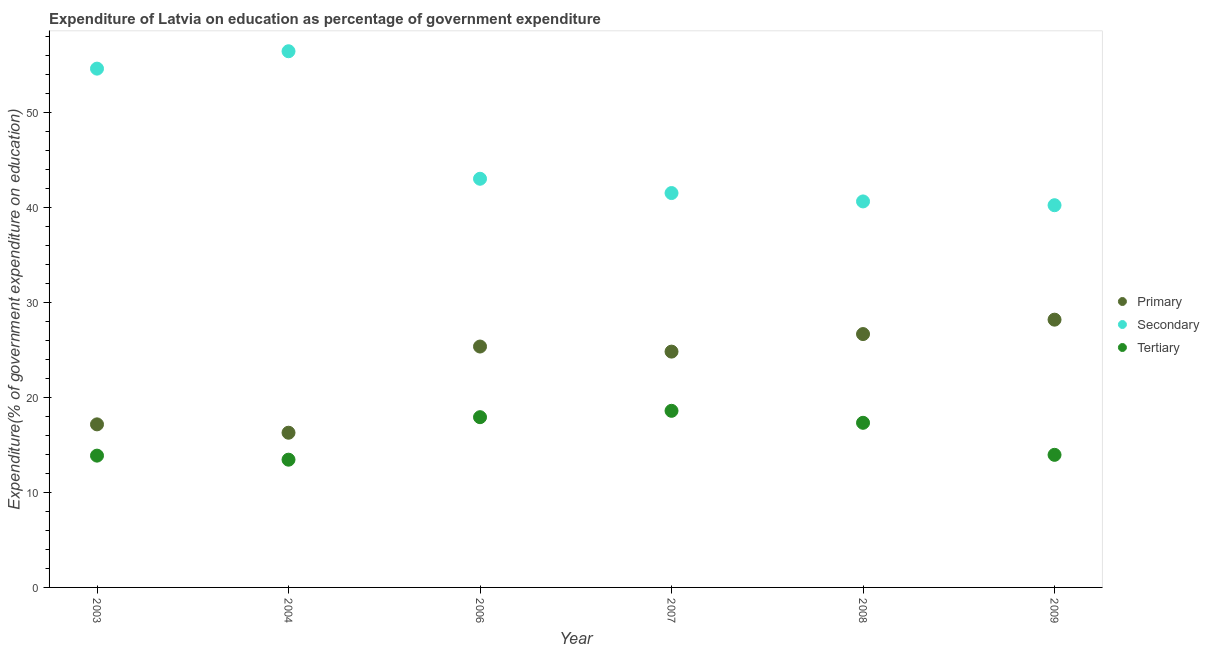Is the number of dotlines equal to the number of legend labels?
Your answer should be compact. Yes. What is the expenditure on primary education in 2007?
Ensure brevity in your answer.  24.82. Across all years, what is the maximum expenditure on secondary education?
Give a very brief answer. 56.45. Across all years, what is the minimum expenditure on secondary education?
Keep it short and to the point. 40.24. In which year was the expenditure on tertiary education minimum?
Your answer should be compact. 2004. What is the total expenditure on secondary education in the graph?
Keep it short and to the point. 276.47. What is the difference between the expenditure on tertiary education in 2004 and that in 2008?
Offer a terse response. -3.88. What is the difference between the expenditure on primary education in 2009 and the expenditure on secondary education in 2008?
Your response must be concise. -12.45. What is the average expenditure on tertiary education per year?
Your answer should be compact. 15.85. In the year 2004, what is the difference between the expenditure on tertiary education and expenditure on secondary education?
Your answer should be compact. -43. In how many years, is the expenditure on primary education greater than 20 %?
Keep it short and to the point. 4. What is the ratio of the expenditure on secondary education in 2004 to that in 2009?
Your answer should be compact. 1.4. Is the expenditure on tertiary education in 2004 less than that in 2008?
Your response must be concise. Yes. What is the difference between the highest and the second highest expenditure on primary education?
Provide a short and direct response. 1.52. What is the difference between the highest and the lowest expenditure on primary education?
Provide a short and direct response. 11.9. In how many years, is the expenditure on tertiary education greater than the average expenditure on tertiary education taken over all years?
Your response must be concise. 3. Is it the case that in every year, the sum of the expenditure on primary education and expenditure on secondary education is greater than the expenditure on tertiary education?
Your answer should be compact. Yes. Is the expenditure on secondary education strictly less than the expenditure on primary education over the years?
Keep it short and to the point. No. How many dotlines are there?
Provide a succinct answer. 3. How many years are there in the graph?
Ensure brevity in your answer.  6. Does the graph contain any zero values?
Ensure brevity in your answer.  No. Does the graph contain grids?
Offer a terse response. No. Where does the legend appear in the graph?
Provide a succinct answer. Center right. What is the title of the graph?
Offer a very short reply. Expenditure of Latvia on education as percentage of government expenditure. What is the label or title of the X-axis?
Provide a succinct answer. Year. What is the label or title of the Y-axis?
Make the answer very short. Expenditure(% of government expenditure on education). What is the Expenditure(% of government expenditure on education) in Primary in 2003?
Your answer should be compact. 17.17. What is the Expenditure(% of government expenditure on education) of Secondary in 2003?
Give a very brief answer. 54.61. What is the Expenditure(% of government expenditure on education) in Tertiary in 2003?
Offer a terse response. 13.87. What is the Expenditure(% of government expenditure on education) in Primary in 2004?
Make the answer very short. 16.29. What is the Expenditure(% of government expenditure on education) of Secondary in 2004?
Provide a short and direct response. 56.45. What is the Expenditure(% of government expenditure on education) in Tertiary in 2004?
Your response must be concise. 13.45. What is the Expenditure(% of government expenditure on education) of Primary in 2006?
Your answer should be compact. 25.36. What is the Expenditure(% of government expenditure on education) in Secondary in 2006?
Offer a terse response. 43.02. What is the Expenditure(% of government expenditure on education) in Tertiary in 2006?
Offer a terse response. 17.92. What is the Expenditure(% of government expenditure on education) of Primary in 2007?
Offer a terse response. 24.82. What is the Expenditure(% of government expenditure on education) in Secondary in 2007?
Your answer should be compact. 41.52. What is the Expenditure(% of government expenditure on education) of Tertiary in 2007?
Keep it short and to the point. 18.59. What is the Expenditure(% of government expenditure on education) in Primary in 2008?
Provide a short and direct response. 26.67. What is the Expenditure(% of government expenditure on education) in Secondary in 2008?
Ensure brevity in your answer.  40.64. What is the Expenditure(% of government expenditure on education) of Tertiary in 2008?
Provide a short and direct response. 17.33. What is the Expenditure(% of government expenditure on education) of Primary in 2009?
Ensure brevity in your answer.  28.19. What is the Expenditure(% of government expenditure on education) of Secondary in 2009?
Offer a very short reply. 40.24. What is the Expenditure(% of government expenditure on education) of Tertiary in 2009?
Offer a terse response. 13.96. Across all years, what is the maximum Expenditure(% of government expenditure on education) in Primary?
Ensure brevity in your answer.  28.19. Across all years, what is the maximum Expenditure(% of government expenditure on education) of Secondary?
Offer a terse response. 56.45. Across all years, what is the maximum Expenditure(% of government expenditure on education) of Tertiary?
Your answer should be compact. 18.59. Across all years, what is the minimum Expenditure(% of government expenditure on education) of Primary?
Offer a very short reply. 16.29. Across all years, what is the minimum Expenditure(% of government expenditure on education) of Secondary?
Give a very brief answer. 40.24. Across all years, what is the minimum Expenditure(% of government expenditure on education) of Tertiary?
Give a very brief answer. 13.45. What is the total Expenditure(% of government expenditure on education) of Primary in the graph?
Ensure brevity in your answer.  138.5. What is the total Expenditure(% of government expenditure on education) of Secondary in the graph?
Your answer should be compact. 276.47. What is the total Expenditure(% of government expenditure on education) in Tertiary in the graph?
Your answer should be very brief. 95.13. What is the difference between the Expenditure(% of government expenditure on education) of Primary in 2003 and that in 2004?
Offer a terse response. 0.88. What is the difference between the Expenditure(% of government expenditure on education) in Secondary in 2003 and that in 2004?
Keep it short and to the point. -1.83. What is the difference between the Expenditure(% of government expenditure on education) in Tertiary in 2003 and that in 2004?
Your response must be concise. 0.43. What is the difference between the Expenditure(% of government expenditure on education) of Primary in 2003 and that in 2006?
Your answer should be very brief. -8.19. What is the difference between the Expenditure(% of government expenditure on education) of Secondary in 2003 and that in 2006?
Provide a short and direct response. 11.59. What is the difference between the Expenditure(% of government expenditure on education) of Tertiary in 2003 and that in 2006?
Provide a short and direct response. -4.05. What is the difference between the Expenditure(% of government expenditure on education) of Primary in 2003 and that in 2007?
Make the answer very short. -7.66. What is the difference between the Expenditure(% of government expenditure on education) of Secondary in 2003 and that in 2007?
Offer a terse response. 13.1. What is the difference between the Expenditure(% of government expenditure on education) in Tertiary in 2003 and that in 2007?
Give a very brief answer. -4.72. What is the difference between the Expenditure(% of government expenditure on education) in Primary in 2003 and that in 2008?
Offer a terse response. -9.51. What is the difference between the Expenditure(% of government expenditure on education) of Secondary in 2003 and that in 2008?
Your answer should be very brief. 13.98. What is the difference between the Expenditure(% of government expenditure on education) in Tertiary in 2003 and that in 2008?
Ensure brevity in your answer.  -3.46. What is the difference between the Expenditure(% of government expenditure on education) in Primary in 2003 and that in 2009?
Your answer should be very brief. -11.02. What is the difference between the Expenditure(% of government expenditure on education) of Secondary in 2003 and that in 2009?
Your answer should be very brief. 14.38. What is the difference between the Expenditure(% of government expenditure on education) in Tertiary in 2003 and that in 2009?
Ensure brevity in your answer.  -0.08. What is the difference between the Expenditure(% of government expenditure on education) in Primary in 2004 and that in 2006?
Your answer should be very brief. -9.07. What is the difference between the Expenditure(% of government expenditure on education) in Secondary in 2004 and that in 2006?
Make the answer very short. 13.42. What is the difference between the Expenditure(% of government expenditure on education) of Tertiary in 2004 and that in 2006?
Keep it short and to the point. -4.47. What is the difference between the Expenditure(% of government expenditure on education) of Primary in 2004 and that in 2007?
Offer a terse response. -8.54. What is the difference between the Expenditure(% of government expenditure on education) of Secondary in 2004 and that in 2007?
Offer a terse response. 14.93. What is the difference between the Expenditure(% of government expenditure on education) of Tertiary in 2004 and that in 2007?
Your answer should be compact. -5.14. What is the difference between the Expenditure(% of government expenditure on education) in Primary in 2004 and that in 2008?
Your answer should be very brief. -10.39. What is the difference between the Expenditure(% of government expenditure on education) of Secondary in 2004 and that in 2008?
Your answer should be very brief. 15.81. What is the difference between the Expenditure(% of government expenditure on education) in Tertiary in 2004 and that in 2008?
Ensure brevity in your answer.  -3.88. What is the difference between the Expenditure(% of government expenditure on education) of Primary in 2004 and that in 2009?
Ensure brevity in your answer.  -11.9. What is the difference between the Expenditure(% of government expenditure on education) of Secondary in 2004 and that in 2009?
Keep it short and to the point. 16.21. What is the difference between the Expenditure(% of government expenditure on education) in Tertiary in 2004 and that in 2009?
Your answer should be very brief. -0.51. What is the difference between the Expenditure(% of government expenditure on education) of Primary in 2006 and that in 2007?
Make the answer very short. 0.54. What is the difference between the Expenditure(% of government expenditure on education) in Secondary in 2006 and that in 2007?
Your response must be concise. 1.5. What is the difference between the Expenditure(% of government expenditure on education) of Tertiary in 2006 and that in 2007?
Provide a short and direct response. -0.67. What is the difference between the Expenditure(% of government expenditure on education) in Primary in 2006 and that in 2008?
Provide a short and direct response. -1.31. What is the difference between the Expenditure(% of government expenditure on education) in Secondary in 2006 and that in 2008?
Ensure brevity in your answer.  2.39. What is the difference between the Expenditure(% of government expenditure on education) of Tertiary in 2006 and that in 2008?
Your answer should be compact. 0.59. What is the difference between the Expenditure(% of government expenditure on education) in Primary in 2006 and that in 2009?
Ensure brevity in your answer.  -2.83. What is the difference between the Expenditure(% of government expenditure on education) in Secondary in 2006 and that in 2009?
Offer a very short reply. 2.78. What is the difference between the Expenditure(% of government expenditure on education) of Tertiary in 2006 and that in 2009?
Provide a short and direct response. 3.97. What is the difference between the Expenditure(% of government expenditure on education) of Primary in 2007 and that in 2008?
Keep it short and to the point. -1.85. What is the difference between the Expenditure(% of government expenditure on education) in Secondary in 2007 and that in 2008?
Your response must be concise. 0.88. What is the difference between the Expenditure(% of government expenditure on education) in Tertiary in 2007 and that in 2008?
Your answer should be very brief. 1.26. What is the difference between the Expenditure(% of government expenditure on education) of Primary in 2007 and that in 2009?
Provide a short and direct response. -3.36. What is the difference between the Expenditure(% of government expenditure on education) of Secondary in 2007 and that in 2009?
Ensure brevity in your answer.  1.28. What is the difference between the Expenditure(% of government expenditure on education) in Tertiary in 2007 and that in 2009?
Offer a very short reply. 4.63. What is the difference between the Expenditure(% of government expenditure on education) of Primary in 2008 and that in 2009?
Your response must be concise. -1.52. What is the difference between the Expenditure(% of government expenditure on education) in Secondary in 2008 and that in 2009?
Provide a succinct answer. 0.4. What is the difference between the Expenditure(% of government expenditure on education) of Tertiary in 2008 and that in 2009?
Provide a short and direct response. 3.37. What is the difference between the Expenditure(% of government expenditure on education) of Primary in 2003 and the Expenditure(% of government expenditure on education) of Secondary in 2004?
Make the answer very short. -39.28. What is the difference between the Expenditure(% of government expenditure on education) in Primary in 2003 and the Expenditure(% of government expenditure on education) in Tertiary in 2004?
Provide a succinct answer. 3.72. What is the difference between the Expenditure(% of government expenditure on education) of Secondary in 2003 and the Expenditure(% of government expenditure on education) of Tertiary in 2004?
Provide a succinct answer. 41.17. What is the difference between the Expenditure(% of government expenditure on education) in Primary in 2003 and the Expenditure(% of government expenditure on education) in Secondary in 2006?
Make the answer very short. -25.86. What is the difference between the Expenditure(% of government expenditure on education) in Primary in 2003 and the Expenditure(% of government expenditure on education) in Tertiary in 2006?
Provide a succinct answer. -0.76. What is the difference between the Expenditure(% of government expenditure on education) in Secondary in 2003 and the Expenditure(% of government expenditure on education) in Tertiary in 2006?
Ensure brevity in your answer.  36.69. What is the difference between the Expenditure(% of government expenditure on education) in Primary in 2003 and the Expenditure(% of government expenditure on education) in Secondary in 2007?
Provide a succinct answer. -24.35. What is the difference between the Expenditure(% of government expenditure on education) in Primary in 2003 and the Expenditure(% of government expenditure on education) in Tertiary in 2007?
Offer a terse response. -1.42. What is the difference between the Expenditure(% of government expenditure on education) in Secondary in 2003 and the Expenditure(% of government expenditure on education) in Tertiary in 2007?
Provide a short and direct response. 36.02. What is the difference between the Expenditure(% of government expenditure on education) of Primary in 2003 and the Expenditure(% of government expenditure on education) of Secondary in 2008?
Offer a very short reply. -23.47. What is the difference between the Expenditure(% of government expenditure on education) in Primary in 2003 and the Expenditure(% of government expenditure on education) in Tertiary in 2008?
Your answer should be compact. -0.16. What is the difference between the Expenditure(% of government expenditure on education) of Secondary in 2003 and the Expenditure(% of government expenditure on education) of Tertiary in 2008?
Your response must be concise. 37.28. What is the difference between the Expenditure(% of government expenditure on education) of Primary in 2003 and the Expenditure(% of government expenditure on education) of Secondary in 2009?
Provide a succinct answer. -23.07. What is the difference between the Expenditure(% of government expenditure on education) in Primary in 2003 and the Expenditure(% of government expenditure on education) in Tertiary in 2009?
Your response must be concise. 3.21. What is the difference between the Expenditure(% of government expenditure on education) of Secondary in 2003 and the Expenditure(% of government expenditure on education) of Tertiary in 2009?
Provide a short and direct response. 40.66. What is the difference between the Expenditure(% of government expenditure on education) in Primary in 2004 and the Expenditure(% of government expenditure on education) in Secondary in 2006?
Your answer should be very brief. -26.74. What is the difference between the Expenditure(% of government expenditure on education) of Primary in 2004 and the Expenditure(% of government expenditure on education) of Tertiary in 2006?
Make the answer very short. -1.64. What is the difference between the Expenditure(% of government expenditure on education) in Secondary in 2004 and the Expenditure(% of government expenditure on education) in Tertiary in 2006?
Provide a succinct answer. 38.52. What is the difference between the Expenditure(% of government expenditure on education) in Primary in 2004 and the Expenditure(% of government expenditure on education) in Secondary in 2007?
Offer a very short reply. -25.23. What is the difference between the Expenditure(% of government expenditure on education) of Primary in 2004 and the Expenditure(% of government expenditure on education) of Tertiary in 2007?
Your answer should be compact. -2.3. What is the difference between the Expenditure(% of government expenditure on education) in Secondary in 2004 and the Expenditure(% of government expenditure on education) in Tertiary in 2007?
Your response must be concise. 37.85. What is the difference between the Expenditure(% of government expenditure on education) in Primary in 2004 and the Expenditure(% of government expenditure on education) in Secondary in 2008?
Your answer should be compact. -24.35. What is the difference between the Expenditure(% of government expenditure on education) in Primary in 2004 and the Expenditure(% of government expenditure on education) in Tertiary in 2008?
Offer a terse response. -1.04. What is the difference between the Expenditure(% of government expenditure on education) in Secondary in 2004 and the Expenditure(% of government expenditure on education) in Tertiary in 2008?
Offer a terse response. 39.11. What is the difference between the Expenditure(% of government expenditure on education) of Primary in 2004 and the Expenditure(% of government expenditure on education) of Secondary in 2009?
Provide a short and direct response. -23.95. What is the difference between the Expenditure(% of government expenditure on education) in Primary in 2004 and the Expenditure(% of government expenditure on education) in Tertiary in 2009?
Provide a succinct answer. 2.33. What is the difference between the Expenditure(% of government expenditure on education) of Secondary in 2004 and the Expenditure(% of government expenditure on education) of Tertiary in 2009?
Keep it short and to the point. 42.49. What is the difference between the Expenditure(% of government expenditure on education) of Primary in 2006 and the Expenditure(% of government expenditure on education) of Secondary in 2007?
Your answer should be compact. -16.16. What is the difference between the Expenditure(% of government expenditure on education) in Primary in 2006 and the Expenditure(% of government expenditure on education) in Tertiary in 2007?
Make the answer very short. 6.77. What is the difference between the Expenditure(% of government expenditure on education) in Secondary in 2006 and the Expenditure(% of government expenditure on education) in Tertiary in 2007?
Give a very brief answer. 24.43. What is the difference between the Expenditure(% of government expenditure on education) in Primary in 2006 and the Expenditure(% of government expenditure on education) in Secondary in 2008?
Provide a short and direct response. -15.28. What is the difference between the Expenditure(% of government expenditure on education) in Primary in 2006 and the Expenditure(% of government expenditure on education) in Tertiary in 2008?
Ensure brevity in your answer.  8.03. What is the difference between the Expenditure(% of government expenditure on education) of Secondary in 2006 and the Expenditure(% of government expenditure on education) of Tertiary in 2008?
Offer a very short reply. 25.69. What is the difference between the Expenditure(% of government expenditure on education) of Primary in 2006 and the Expenditure(% of government expenditure on education) of Secondary in 2009?
Give a very brief answer. -14.88. What is the difference between the Expenditure(% of government expenditure on education) of Primary in 2006 and the Expenditure(% of government expenditure on education) of Tertiary in 2009?
Offer a terse response. 11.4. What is the difference between the Expenditure(% of government expenditure on education) of Secondary in 2006 and the Expenditure(% of government expenditure on education) of Tertiary in 2009?
Your answer should be compact. 29.06. What is the difference between the Expenditure(% of government expenditure on education) of Primary in 2007 and the Expenditure(% of government expenditure on education) of Secondary in 2008?
Your answer should be very brief. -15.81. What is the difference between the Expenditure(% of government expenditure on education) in Primary in 2007 and the Expenditure(% of government expenditure on education) in Tertiary in 2008?
Provide a short and direct response. 7.49. What is the difference between the Expenditure(% of government expenditure on education) of Secondary in 2007 and the Expenditure(% of government expenditure on education) of Tertiary in 2008?
Your answer should be compact. 24.19. What is the difference between the Expenditure(% of government expenditure on education) in Primary in 2007 and the Expenditure(% of government expenditure on education) in Secondary in 2009?
Your response must be concise. -15.41. What is the difference between the Expenditure(% of government expenditure on education) in Primary in 2007 and the Expenditure(% of government expenditure on education) in Tertiary in 2009?
Your answer should be very brief. 10.87. What is the difference between the Expenditure(% of government expenditure on education) of Secondary in 2007 and the Expenditure(% of government expenditure on education) of Tertiary in 2009?
Provide a short and direct response. 27.56. What is the difference between the Expenditure(% of government expenditure on education) in Primary in 2008 and the Expenditure(% of government expenditure on education) in Secondary in 2009?
Your response must be concise. -13.56. What is the difference between the Expenditure(% of government expenditure on education) in Primary in 2008 and the Expenditure(% of government expenditure on education) in Tertiary in 2009?
Offer a terse response. 12.71. What is the difference between the Expenditure(% of government expenditure on education) of Secondary in 2008 and the Expenditure(% of government expenditure on education) of Tertiary in 2009?
Your answer should be very brief. 26.68. What is the average Expenditure(% of government expenditure on education) of Primary per year?
Your response must be concise. 23.08. What is the average Expenditure(% of government expenditure on education) in Secondary per year?
Make the answer very short. 46.08. What is the average Expenditure(% of government expenditure on education) in Tertiary per year?
Provide a succinct answer. 15.85. In the year 2003, what is the difference between the Expenditure(% of government expenditure on education) in Primary and Expenditure(% of government expenditure on education) in Secondary?
Ensure brevity in your answer.  -37.45. In the year 2003, what is the difference between the Expenditure(% of government expenditure on education) in Primary and Expenditure(% of government expenditure on education) in Tertiary?
Make the answer very short. 3.29. In the year 2003, what is the difference between the Expenditure(% of government expenditure on education) in Secondary and Expenditure(% of government expenditure on education) in Tertiary?
Provide a succinct answer. 40.74. In the year 2004, what is the difference between the Expenditure(% of government expenditure on education) in Primary and Expenditure(% of government expenditure on education) in Secondary?
Keep it short and to the point. -40.16. In the year 2004, what is the difference between the Expenditure(% of government expenditure on education) in Primary and Expenditure(% of government expenditure on education) in Tertiary?
Give a very brief answer. 2.84. In the year 2004, what is the difference between the Expenditure(% of government expenditure on education) of Secondary and Expenditure(% of government expenditure on education) of Tertiary?
Offer a terse response. 43. In the year 2006, what is the difference between the Expenditure(% of government expenditure on education) in Primary and Expenditure(% of government expenditure on education) in Secondary?
Provide a short and direct response. -17.66. In the year 2006, what is the difference between the Expenditure(% of government expenditure on education) in Primary and Expenditure(% of government expenditure on education) in Tertiary?
Keep it short and to the point. 7.44. In the year 2006, what is the difference between the Expenditure(% of government expenditure on education) in Secondary and Expenditure(% of government expenditure on education) in Tertiary?
Offer a very short reply. 25.1. In the year 2007, what is the difference between the Expenditure(% of government expenditure on education) in Primary and Expenditure(% of government expenditure on education) in Secondary?
Offer a terse response. -16.69. In the year 2007, what is the difference between the Expenditure(% of government expenditure on education) of Primary and Expenditure(% of government expenditure on education) of Tertiary?
Provide a succinct answer. 6.23. In the year 2007, what is the difference between the Expenditure(% of government expenditure on education) of Secondary and Expenditure(% of government expenditure on education) of Tertiary?
Provide a succinct answer. 22.93. In the year 2008, what is the difference between the Expenditure(% of government expenditure on education) of Primary and Expenditure(% of government expenditure on education) of Secondary?
Keep it short and to the point. -13.96. In the year 2008, what is the difference between the Expenditure(% of government expenditure on education) of Primary and Expenditure(% of government expenditure on education) of Tertiary?
Your answer should be very brief. 9.34. In the year 2008, what is the difference between the Expenditure(% of government expenditure on education) in Secondary and Expenditure(% of government expenditure on education) in Tertiary?
Give a very brief answer. 23.3. In the year 2009, what is the difference between the Expenditure(% of government expenditure on education) of Primary and Expenditure(% of government expenditure on education) of Secondary?
Your answer should be compact. -12.05. In the year 2009, what is the difference between the Expenditure(% of government expenditure on education) of Primary and Expenditure(% of government expenditure on education) of Tertiary?
Provide a short and direct response. 14.23. In the year 2009, what is the difference between the Expenditure(% of government expenditure on education) of Secondary and Expenditure(% of government expenditure on education) of Tertiary?
Your answer should be very brief. 26.28. What is the ratio of the Expenditure(% of government expenditure on education) in Primary in 2003 to that in 2004?
Your answer should be very brief. 1.05. What is the ratio of the Expenditure(% of government expenditure on education) in Secondary in 2003 to that in 2004?
Keep it short and to the point. 0.97. What is the ratio of the Expenditure(% of government expenditure on education) of Tertiary in 2003 to that in 2004?
Offer a very short reply. 1.03. What is the ratio of the Expenditure(% of government expenditure on education) in Primary in 2003 to that in 2006?
Provide a short and direct response. 0.68. What is the ratio of the Expenditure(% of government expenditure on education) of Secondary in 2003 to that in 2006?
Offer a very short reply. 1.27. What is the ratio of the Expenditure(% of government expenditure on education) in Tertiary in 2003 to that in 2006?
Offer a very short reply. 0.77. What is the ratio of the Expenditure(% of government expenditure on education) in Primary in 2003 to that in 2007?
Provide a succinct answer. 0.69. What is the ratio of the Expenditure(% of government expenditure on education) in Secondary in 2003 to that in 2007?
Ensure brevity in your answer.  1.32. What is the ratio of the Expenditure(% of government expenditure on education) in Tertiary in 2003 to that in 2007?
Your response must be concise. 0.75. What is the ratio of the Expenditure(% of government expenditure on education) in Primary in 2003 to that in 2008?
Make the answer very short. 0.64. What is the ratio of the Expenditure(% of government expenditure on education) in Secondary in 2003 to that in 2008?
Offer a very short reply. 1.34. What is the ratio of the Expenditure(% of government expenditure on education) in Tertiary in 2003 to that in 2008?
Your answer should be compact. 0.8. What is the ratio of the Expenditure(% of government expenditure on education) of Primary in 2003 to that in 2009?
Offer a very short reply. 0.61. What is the ratio of the Expenditure(% of government expenditure on education) in Secondary in 2003 to that in 2009?
Your answer should be very brief. 1.36. What is the ratio of the Expenditure(% of government expenditure on education) in Tertiary in 2003 to that in 2009?
Make the answer very short. 0.99. What is the ratio of the Expenditure(% of government expenditure on education) of Primary in 2004 to that in 2006?
Your answer should be compact. 0.64. What is the ratio of the Expenditure(% of government expenditure on education) of Secondary in 2004 to that in 2006?
Give a very brief answer. 1.31. What is the ratio of the Expenditure(% of government expenditure on education) of Tertiary in 2004 to that in 2006?
Make the answer very short. 0.75. What is the ratio of the Expenditure(% of government expenditure on education) of Primary in 2004 to that in 2007?
Ensure brevity in your answer.  0.66. What is the ratio of the Expenditure(% of government expenditure on education) in Secondary in 2004 to that in 2007?
Provide a short and direct response. 1.36. What is the ratio of the Expenditure(% of government expenditure on education) in Tertiary in 2004 to that in 2007?
Provide a succinct answer. 0.72. What is the ratio of the Expenditure(% of government expenditure on education) of Primary in 2004 to that in 2008?
Your answer should be very brief. 0.61. What is the ratio of the Expenditure(% of government expenditure on education) of Secondary in 2004 to that in 2008?
Give a very brief answer. 1.39. What is the ratio of the Expenditure(% of government expenditure on education) in Tertiary in 2004 to that in 2008?
Your answer should be compact. 0.78. What is the ratio of the Expenditure(% of government expenditure on education) in Primary in 2004 to that in 2009?
Your answer should be compact. 0.58. What is the ratio of the Expenditure(% of government expenditure on education) of Secondary in 2004 to that in 2009?
Give a very brief answer. 1.4. What is the ratio of the Expenditure(% of government expenditure on education) of Tertiary in 2004 to that in 2009?
Your answer should be compact. 0.96. What is the ratio of the Expenditure(% of government expenditure on education) of Primary in 2006 to that in 2007?
Provide a succinct answer. 1.02. What is the ratio of the Expenditure(% of government expenditure on education) in Secondary in 2006 to that in 2007?
Offer a terse response. 1.04. What is the ratio of the Expenditure(% of government expenditure on education) in Tertiary in 2006 to that in 2007?
Ensure brevity in your answer.  0.96. What is the ratio of the Expenditure(% of government expenditure on education) of Primary in 2006 to that in 2008?
Make the answer very short. 0.95. What is the ratio of the Expenditure(% of government expenditure on education) in Secondary in 2006 to that in 2008?
Keep it short and to the point. 1.06. What is the ratio of the Expenditure(% of government expenditure on education) of Tertiary in 2006 to that in 2008?
Keep it short and to the point. 1.03. What is the ratio of the Expenditure(% of government expenditure on education) in Primary in 2006 to that in 2009?
Provide a short and direct response. 0.9. What is the ratio of the Expenditure(% of government expenditure on education) in Secondary in 2006 to that in 2009?
Your response must be concise. 1.07. What is the ratio of the Expenditure(% of government expenditure on education) of Tertiary in 2006 to that in 2009?
Offer a very short reply. 1.28. What is the ratio of the Expenditure(% of government expenditure on education) of Primary in 2007 to that in 2008?
Offer a terse response. 0.93. What is the ratio of the Expenditure(% of government expenditure on education) of Secondary in 2007 to that in 2008?
Give a very brief answer. 1.02. What is the ratio of the Expenditure(% of government expenditure on education) of Tertiary in 2007 to that in 2008?
Offer a very short reply. 1.07. What is the ratio of the Expenditure(% of government expenditure on education) of Primary in 2007 to that in 2009?
Make the answer very short. 0.88. What is the ratio of the Expenditure(% of government expenditure on education) in Secondary in 2007 to that in 2009?
Your response must be concise. 1.03. What is the ratio of the Expenditure(% of government expenditure on education) in Tertiary in 2007 to that in 2009?
Give a very brief answer. 1.33. What is the ratio of the Expenditure(% of government expenditure on education) of Primary in 2008 to that in 2009?
Give a very brief answer. 0.95. What is the ratio of the Expenditure(% of government expenditure on education) in Secondary in 2008 to that in 2009?
Your answer should be very brief. 1.01. What is the ratio of the Expenditure(% of government expenditure on education) in Tertiary in 2008 to that in 2009?
Provide a short and direct response. 1.24. What is the difference between the highest and the second highest Expenditure(% of government expenditure on education) of Primary?
Give a very brief answer. 1.52. What is the difference between the highest and the second highest Expenditure(% of government expenditure on education) in Secondary?
Offer a terse response. 1.83. What is the difference between the highest and the second highest Expenditure(% of government expenditure on education) of Tertiary?
Ensure brevity in your answer.  0.67. What is the difference between the highest and the lowest Expenditure(% of government expenditure on education) in Primary?
Offer a terse response. 11.9. What is the difference between the highest and the lowest Expenditure(% of government expenditure on education) of Secondary?
Give a very brief answer. 16.21. What is the difference between the highest and the lowest Expenditure(% of government expenditure on education) of Tertiary?
Your answer should be compact. 5.14. 